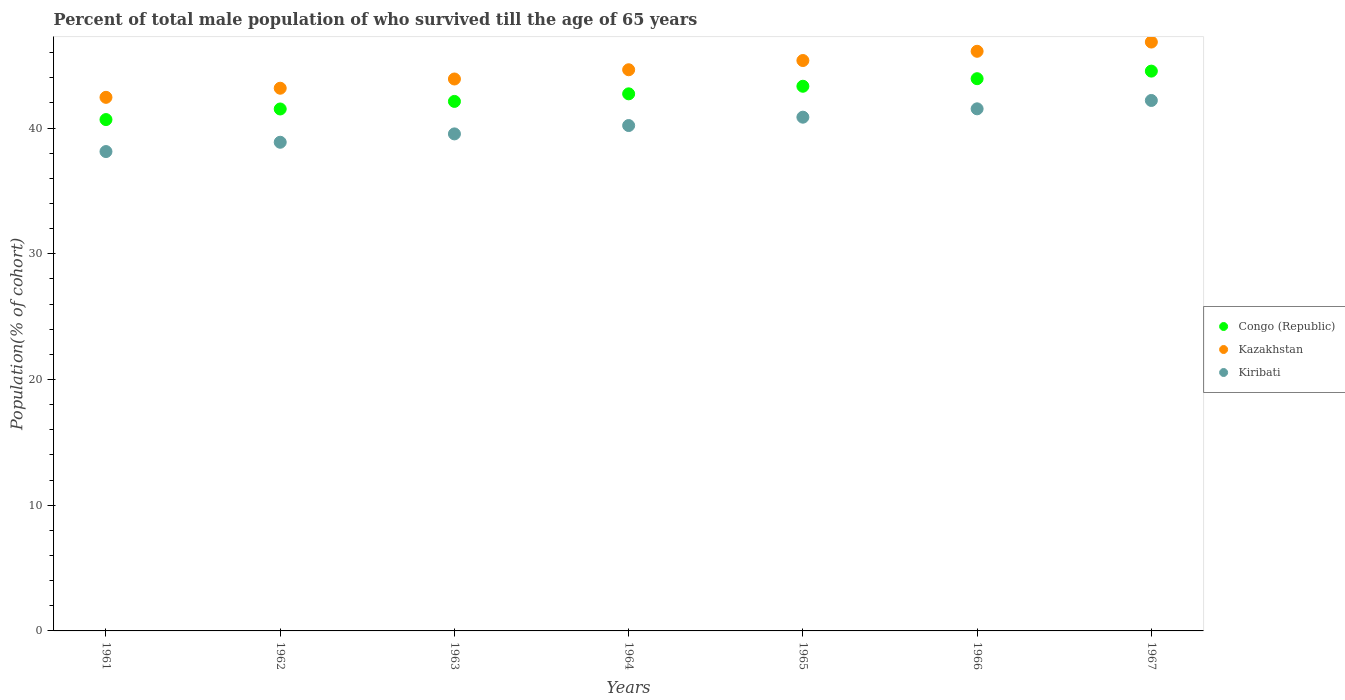How many different coloured dotlines are there?
Offer a very short reply. 3. Is the number of dotlines equal to the number of legend labels?
Your answer should be very brief. Yes. What is the percentage of total male population who survived till the age of 65 years in Congo (Republic) in 1961?
Your answer should be very brief. 40.68. Across all years, what is the maximum percentage of total male population who survived till the age of 65 years in Congo (Republic)?
Your answer should be compact. 44.53. Across all years, what is the minimum percentage of total male population who survived till the age of 65 years in Kiribati?
Offer a very short reply. 38.13. In which year was the percentage of total male population who survived till the age of 65 years in Kazakhstan maximum?
Provide a succinct answer. 1967. In which year was the percentage of total male population who survived till the age of 65 years in Kazakhstan minimum?
Your answer should be compact. 1961. What is the total percentage of total male population who survived till the age of 65 years in Kazakhstan in the graph?
Make the answer very short. 312.5. What is the difference between the percentage of total male population who survived till the age of 65 years in Congo (Republic) in 1965 and that in 1966?
Your answer should be very brief. -0.6. What is the difference between the percentage of total male population who survived till the age of 65 years in Kazakhstan in 1967 and the percentage of total male population who survived till the age of 65 years in Congo (Republic) in 1964?
Your answer should be very brief. 4.12. What is the average percentage of total male population who survived till the age of 65 years in Congo (Republic) per year?
Ensure brevity in your answer.  42.69. In the year 1965, what is the difference between the percentage of total male population who survived till the age of 65 years in Congo (Republic) and percentage of total male population who survived till the age of 65 years in Kiribati?
Make the answer very short. 2.46. What is the ratio of the percentage of total male population who survived till the age of 65 years in Congo (Republic) in 1963 to that in 1967?
Your response must be concise. 0.95. Is the percentage of total male population who survived till the age of 65 years in Kiribati in 1961 less than that in 1964?
Provide a succinct answer. Yes. Is the difference between the percentage of total male population who survived till the age of 65 years in Congo (Republic) in 1961 and 1962 greater than the difference between the percentage of total male population who survived till the age of 65 years in Kiribati in 1961 and 1962?
Keep it short and to the point. No. What is the difference between the highest and the second highest percentage of total male population who survived till the age of 65 years in Kazakhstan?
Ensure brevity in your answer.  0.73. What is the difference between the highest and the lowest percentage of total male population who survived till the age of 65 years in Kiribati?
Offer a very short reply. 4.06. Is it the case that in every year, the sum of the percentage of total male population who survived till the age of 65 years in Congo (Republic) and percentage of total male population who survived till the age of 65 years in Kazakhstan  is greater than the percentage of total male population who survived till the age of 65 years in Kiribati?
Your answer should be compact. Yes. Is the percentage of total male population who survived till the age of 65 years in Kiribati strictly greater than the percentage of total male population who survived till the age of 65 years in Kazakhstan over the years?
Your response must be concise. No. Is the percentage of total male population who survived till the age of 65 years in Congo (Republic) strictly less than the percentage of total male population who survived till the age of 65 years in Kazakhstan over the years?
Your response must be concise. Yes. How many dotlines are there?
Your response must be concise. 3. How many years are there in the graph?
Your answer should be compact. 7. Does the graph contain any zero values?
Keep it short and to the point. No. Where does the legend appear in the graph?
Keep it short and to the point. Center right. How many legend labels are there?
Your answer should be compact. 3. What is the title of the graph?
Give a very brief answer. Percent of total male population of who survived till the age of 65 years. Does "Belgium" appear as one of the legend labels in the graph?
Make the answer very short. No. What is the label or title of the X-axis?
Keep it short and to the point. Years. What is the label or title of the Y-axis?
Give a very brief answer. Population(% of cohort). What is the Population(% of cohort) of Congo (Republic) in 1961?
Your answer should be compact. 40.68. What is the Population(% of cohort) of Kazakhstan in 1961?
Provide a short and direct response. 42.45. What is the Population(% of cohort) in Kiribati in 1961?
Provide a short and direct response. 38.13. What is the Population(% of cohort) of Congo (Republic) in 1962?
Offer a very short reply. 41.52. What is the Population(% of cohort) of Kazakhstan in 1962?
Offer a terse response. 43.17. What is the Population(% of cohort) in Kiribati in 1962?
Ensure brevity in your answer.  38.87. What is the Population(% of cohort) of Congo (Republic) in 1963?
Ensure brevity in your answer.  42.12. What is the Population(% of cohort) in Kazakhstan in 1963?
Give a very brief answer. 43.91. What is the Population(% of cohort) in Kiribati in 1963?
Ensure brevity in your answer.  39.54. What is the Population(% of cohort) of Congo (Republic) in 1964?
Give a very brief answer. 42.73. What is the Population(% of cohort) in Kazakhstan in 1964?
Keep it short and to the point. 44.64. What is the Population(% of cohort) in Kiribati in 1964?
Keep it short and to the point. 40.2. What is the Population(% of cohort) in Congo (Republic) in 1965?
Make the answer very short. 43.33. What is the Population(% of cohort) of Kazakhstan in 1965?
Ensure brevity in your answer.  45.38. What is the Population(% of cohort) in Kiribati in 1965?
Offer a very short reply. 40.87. What is the Population(% of cohort) of Congo (Republic) in 1966?
Offer a terse response. 43.93. What is the Population(% of cohort) of Kazakhstan in 1966?
Your answer should be compact. 46.11. What is the Population(% of cohort) of Kiribati in 1966?
Provide a succinct answer. 41.53. What is the Population(% of cohort) of Congo (Republic) in 1967?
Your response must be concise. 44.53. What is the Population(% of cohort) in Kazakhstan in 1967?
Provide a succinct answer. 46.85. What is the Population(% of cohort) of Kiribati in 1967?
Provide a succinct answer. 42.2. Across all years, what is the maximum Population(% of cohort) of Congo (Republic)?
Offer a very short reply. 44.53. Across all years, what is the maximum Population(% of cohort) in Kazakhstan?
Your answer should be very brief. 46.85. Across all years, what is the maximum Population(% of cohort) in Kiribati?
Offer a very short reply. 42.2. Across all years, what is the minimum Population(% of cohort) of Congo (Republic)?
Your response must be concise. 40.68. Across all years, what is the minimum Population(% of cohort) of Kazakhstan?
Your answer should be compact. 42.45. Across all years, what is the minimum Population(% of cohort) of Kiribati?
Offer a very short reply. 38.13. What is the total Population(% of cohort) of Congo (Republic) in the graph?
Give a very brief answer. 298.84. What is the total Population(% of cohort) of Kazakhstan in the graph?
Offer a very short reply. 312.5. What is the total Population(% of cohort) of Kiribati in the graph?
Keep it short and to the point. 281.35. What is the difference between the Population(% of cohort) in Congo (Republic) in 1961 and that in 1962?
Keep it short and to the point. -0.84. What is the difference between the Population(% of cohort) of Kazakhstan in 1961 and that in 1962?
Ensure brevity in your answer.  -0.73. What is the difference between the Population(% of cohort) of Kiribati in 1961 and that in 1962?
Keep it short and to the point. -0.74. What is the difference between the Population(% of cohort) in Congo (Republic) in 1961 and that in 1963?
Your answer should be compact. -1.45. What is the difference between the Population(% of cohort) of Kazakhstan in 1961 and that in 1963?
Provide a short and direct response. -1.46. What is the difference between the Population(% of cohort) of Kiribati in 1961 and that in 1963?
Make the answer very short. -1.41. What is the difference between the Population(% of cohort) in Congo (Republic) in 1961 and that in 1964?
Give a very brief answer. -2.05. What is the difference between the Population(% of cohort) of Kazakhstan in 1961 and that in 1964?
Ensure brevity in your answer.  -2.19. What is the difference between the Population(% of cohort) of Kiribati in 1961 and that in 1964?
Your answer should be very brief. -2.07. What is the difference between the Population(% of cohort) in Congo (Republic) in 1961 and that in 1965?
Your answer should be compact. -2.65. What is the difference between the Population(% of cohort) in Kazakhstan in 1961 and that in 1965?
Keep it short and to the point. -2.93. What is the difference between the Population(% of cohort) in Kiribati in 1961 and that in 1965?
Ensure brevity in your answer.  -2.73. What is the difference between the Population(% of cohort) in Congo (Republic) in 1961 and that in 1966?
Keep it short and to the point. -3.25. What is the difference between the Population(% of cohort) in Kazakhstan in 1961 and that in 1966?
Your answer should be compact. -3.66. What is the difference between the Population(% of cohort) in Kiribati in 1961 and that in 1966?
Provide a succinct answer. -3.4. What is the difference between the Population(% of cohort) of Congo (Republic) in 1961 and that in 1967?
Give a very brief answer. -3.85. What is the difference between the Population(% of cohort) in Kazakhstan in 1961 and that in 1967?
Your response must be concise. -4.4. What is the difference between the Population(% of cohort) in Kiribati in 1961 and that in 1967?
Offer a very short reply. -4.06. What is the difference between the Population(% of cohort) in Congo (Republic) in 1962 and that in 1963?
Keep it short and to the point. -0.6. What is the difference between the Population(% of cohort) in Kazakhstan in 1962 and that in 1963?
Your response must be concise. -0.73. What is the difference between the Population(% of cohort) of Kiribati in 1962 and that in 1963?
Offer a terse response. -0.66. What is the difference between the Population(% of cohort) in Congo (Republic) in 1962 and that in 1964?
Give a very brief answer. -1.2. What is the difference between the Population(% of cohort) of Kazakhstan in 1962 and that in 1964?
Your answer should be compact. -1.47. What is the difference between the Population(% of cohort) in Kiribati in 1962 and that in 1964?
Ensure brevity in your answer.  -1.33. What is the difference between the Population(% of cohort) of Congo (Republic) in 1962 and that in 1965?
Provide a succinct answer. -1.81. What is the difference between the Population(% of cohort) in Kazakhstan in 1962 and that in 1965?
Your answer should be compact. -2.2. What is the difference between the Population(% of cohort) of Kiribati in 1962 and that in 1965?
Your answer should be compact. -1.99. What is the difference between the Population(% of cohort) in Congo (Republic) in 1962 and that in 1966?
Give a very brief answer. -2.41. What is the difference between the Population(% of cohort) of Kazakhstan in 1962 and that in 1966?
Make the answer very short. -2.94. What is the difference between the Population(% of cohort) in Kiribati in 1962 and that in 1966?
Ensure brevity in your answer.  -2.66. What is the difference between the Population(% of cohort) of Congo (Republic) in 1962 and that in 1967?
Offer a very short reply. -3.01. What is the difference between the Population(% of cohort) of Kazakhstan in 1962 and that in 1967?
Make the answer very short. -3.67. What is the difference between the Population(% of cohort) in Kiribati in 1962 and that in 1967?
Give a very brief answer. -3.32. What is the difference between the Population(% of cohort) of Congo (Republic) in 1963 and that in 1964?
Ensure brevity in your answer.  -0.6. What is the difference between the Population(% of cohort) of Kazakhstan in 1963 and that in 1964?
Your answer should be compact. -0.73. What is the difference between the Population(% of cohort) in Kiribati in 1963 and that in 1964?
Provide a short and direct response. -0.66. What is the difference between the Population(% of cohort) of Congo (Republic) in 1963 and that in 1965?
Provide a succinct answer. -1.2. What is the difference between the Population(% of cohort) in Kazakhstan in 1963 and that in 1965?
Keep it short and to the point. -1.47. What is the difference between the Population(% of cohort) of Kiribati in 1963 and that in 1965?
Offer a very short reply. -1.33. What is the difference between the Population(% of cohort) of Congo (Republic) in 1963 and that in 1966?
Ensure brevity in your answer.  -1.81. What is the difference between the Population(% of cohort) in Kazakhstan in 1963 and that in 1966?
Your answer should be compact. -2.2. What is the difference between the Population(% of cohort) of Kiribati in 1963 and that in 1966?
Your answer should be compact. -1.99. What is the difference between the Population(% of cohort) of Congo (Republic) in 1963 and that in 1967?
Offer a terse response. -2.41. What is the difference between the Population(% of cohort) in Kazakhstan in 1963 and that in 1967?
Your response must be concise. -2.94. What is the difference between the Population(% of cohort) of Kiribati in 1963 and that in 1967?
Your answer should be very brief. -2.66. What is the difference between the Population(% of cohort) in Congo (Republic) in 1964 and that in 1965?
Make the answer very short. -0.6. What is the difference between the Population(% of cohort) of Kazakhstan in 1964 and that in 1965?
Your answer should be compact. -0.73. What is the difference between the Population(% of cohort) of Kiribati in 1964 and that in 1965?
Your answer should be compact. -0.66. What is the difference between the Population(% of cohort) of Congo (Republic) in 1964 and that in 1966?
Offer a terse response. -1.2. What is the difference between the Population(% of cohort) in Kazakhstan in 1964 and that in 1966?
Provide a succinct answer. -1.47. What is the difference between the Population(% of cohort) in Kiribati in 1964 and that in 1966?
Your answer should be compact. -1.33. What is the difference between the Population(% of cohort) of Congo (Republic) in 1964 and that in 1967?
Your response must be concise. -1.81. What is the difference between the Population(% of cohort) of Kazakhstan in 1964 and that in 1967?
Offer a terse response. -2.2. What is the difference between the Population(% of cohort) in Kiribati in 1964 and that in 1967?
Provide a succinct answer. -1.99. What is the difference between the Population(% of cohort) of Congo (Republic) in 1965 and that in 1966?
Your answer should be compact. -0.6. What is the difference between the Population(% of cohort) in Kazakhstan in 1965 and that in 1966?
Offer a very short reply. -0.73. What is the difference between the Population(% of cohort) of Kiribati in 1965 and that in 1966?
Keep it short and to the point. -0.66. What is the difference between the Population(% of cohort) in Congo (Republic) in 1965 and that in 1967?
Your answer should be compact. -1.2. What is the difference between the Population(% of cohort) in Kazakhstan in 1965 and that in 1967?
Keep it short and to the point. -1.47. What is the difference between the Population(% of cohort) of Kiribati in 1965 and that in 1967?
Your response must be concise. -1.33. What is the difference between the Population(% of cohort) in Congo (Republic) in 1966 and that in 1967?
Make the answer very short. -0.6. What is the difference between the Population(% of cohort) of Kazakhstan in 1966 and that in 1967?
Make the answer very short. -0.73. What is the difference between the Population(% of cohort) of Kiribati in 1966 and that in 1967?
Provide a short and direct response. -0.66. What is the difference between the Population(% of cohort) of Congo (Republic) in 1961 and the Population(% of cohort) of Kazakhstan in 1962?
Offer a very short reply. -2.49. What is the difference between the Population(% of cohort) of Congo (Republic) in 1961 and the Population(% of cohort) of Kiribati in 1962?
Ensure brevity in your answer.  1.8. What is the difference between the Population(% of cohort) in Kazakhstan in 1961 and the Population(% of cohort) in Kiribati in 1962?
Ensure brevity in your answer.  3.57. What is the difference between the Population(% of cohort) of Congo (Republic) in 1961 and the Population(% of cohort) of Kazakhstan in 1963?
Keep it short and to the point. -3.23. What is the difference between the Population(% of cohort) of Congo (Republic) in 1961 and the Population(% of cohort) of Kiribati in 1963?
Keep it short and to the point. 1.14. What is the difference between the Population(% of cohort) in Kazakhstan in 1961 and the Population(% of cohort) in Kiribati in 1963?
Offer a terse response. 2.91. What is the difference between the Population(% of cohort) of Congo (Republic) in 1961 and the Population(% of cohort) of Kazakhstan in 1964?
Provide a short and direct response. -3.96. What is the difference between the Population(% of cohort) of Congo (Republic) in 1961 and the Population(% of cohort) of Kiribati in 1964?
Your answer should be very brief. 0.47. What is the difference between the Population(% of cohort) in Kazakhstan in 1961 and the Population(% of cohort) in Kiribati in 1964?
Your answer should be compact. 2.24. What is the difference between the Population(% of cohort) in Congo (Republic) in 1961 and the Population(% of cohort) in Kazakhstan in 1965?
Your answer should be compact. -4.7. What is the difference between the Population(% of cohort) of Congo (Republic) in 1961 and the Population(% of cohort) of Kiribati in 1965?
Give a very brief answer. -0.19. What is the difference between the Population(% of cohort) in Kazakhstan in 1961 and the Population(% of cohort) in Kiribati in 1965?
Give a very brief answer. 1.58. What is the difference between the Population(% of cohort) in Congo (Republic) in 1961 and the Population(% of cohort) in Kazakhstan in 1966?
Make the answer very short. -5.43. What is the difference between the Population(% of cohort) in Congo (Republic) in 1961 and the Population(% of cohort) in Kiribati in 1966?
Keep it short and to the point. -0.85. What is the difference between the Population(% of cohort) in Kazakhstan in 1961 and the Population(% of cohort) in Kiribati in 1966?
Make the answer very short. 0.91. What is the difference between the Population(% of cohort) of Congo (Republic) in 1961 and the Population(% of cohort) of Kazakhstan in 1967?
Make the answer very short. -6.17. What is the difference between the Population(% of cohort) of Congo (Republic) in 1961 and the Population(% of cohort) of Kiribati in 1967?
Offer a very short reply. -1.52. What is the difference between the Population(% of cohort) of Kazakhstan in 1961 and the Population(% of cohort) of Kiribati in 1967?
Ensure brevity in your answer.  0.25. What is the difference between the Population(% of cohort) in Congo (Republic) in 1962 and the Population(% of cohort) in Kazakhstan in 1963?
Provide a short and direct response. -2.39. What is the difference between the Population(% of cohort) in Congo (Republic) in 1962 and the Population(% of cohort) in Kiribati in 1963?
Offer a very short reply. 1.98. What is the difference between the Population(% of cohort) in Kazakhstan in 1962 and the Population(% of cohort) in Kiribati in 1963?
Provide a succinct answer. 3.63. What is the difference between the Population(% of cohort) of Congo (Republic) in 1962 and the Population(% of cohort) of Kazakhstan in 1964?
Offer a very short reply. -3.12. What is the difference between the Population(% of cohort) in Congo (Republic) in 1962 and the Population(% of cohort) in Kiribati in 1964?
Keep it short and to the point. 1.32. What is the difference between the Population(% of cohort) of Kazakhstan in 1962 and the Population(% of cohort) of Kiribati in 1964?
Provide a succinct answer. 2.97. What is the difference between the Population(% of cohort) in Congo (Republic) in 1962 and the Population(% of cohort) in Kazakhstan in 1965?
Your response must be concise. -3.86. What is the difference between the Population(% of cohort) of Congo (Republic) in 1962 and the Population(% of cohort) of Kiribati in 1965?
Provide a short and direct response. 0.65. What is the difference between the Population(% of cohort) of Kazakhstan in 1962 and the Population(% of cohort) of Kiribati in 1965?
Your response must be concise. 2.3. What is the difference between the Population(% of cohort) in Congo (Republic) in 1962 and the Population(% of cohort) in Kazakhstan in 1966?
Provide a short and direct response. -4.59. What is the difference between the Population(% of cohort) of Congo (Republic) in 1962 and the Population(% of cohort) of Kiribati in 1966?
Ensure brevity in your answer.  -0.01. What is the difference between the Population(% of cohort) of Kazakhstan in 1962 and the Population(% of cohort) of Kiribati in 1966?
Provide a short and direct response. 1.64. What is the difference between the Population(% of cohort) of Congo (Republic) in 1962 and the Population(% of cohort) of Kazakhstan in 1967?
Offer a very short reply. -5.32. What is the difference between the Population(% of cohort) of Congo (Republic) in 1962 and the Population(% of cohort) of Kiribati in 1967?
Offer a very short reply. -0.68. What is the difference between the Population(% of cohort) of Kazakhstan in 1962 and the Population(% of cohort) of Kiribati in 1967?
Your answer should be compact. 0.97. What is the difference between the Population(% of cohort) of Congo (Republic) in 1963 and the Population(% of cohort) of Kazakhstan in 1964?
Your answer should be compact. -2.52. What is the difference between the Population(% of cohort) in Congo (Republic) in 1963 and the Population(% of cohort) in Kiribati in 1964?
Make the answer very short. 1.92. What is the difference between the Population(% of cohort) in Kazakhstan in 1963 and the Population(% of cohort) in Kiribati in 1964?
Provide a short and direct response. 3.7. What is the difference between the Population(% of cohort) in Congo (Republic) in 1963 and the Population(% of cohort) in Kazakhstan in 1965?
Offer a terse response. -3.25. What is the difference between the Population(% of cohort) in Congo (Republic) in 1963 and the Population(% of cohort) in Kiribati in 1965?
Your answer should be compact. 1.25. What is the difference between the Population(% of cohort) in Kazakhstan in 1963 and the Population(% of cohort) in Kiribati in 1965?
Keep it short and to the point. 3.04. What is the difference between the Population(% of cohort) in Congo (Republic) in 1963 and the Population(% of cohort) in Kazakhstan in 1966?
Offer a very short reply. -3.99. What is the difference between the Population(% of cohort) of Congo (Republic) in 1963 and the Population(% of cohort) of Kiribati in 1966?
Give a very brief answer. 0.59. What is the difference between the Population(% of cohort) in Kazakhstan in 1963 and the Population(% of cohort) in Kiribati in 1966?
Give a very brief answer. 2.37. What is the difference between the Population(% of cohort) in Congo (Republic) in 1963 and the Population(% of cohort) in Kazakhstan in 1967?
Offer a very short reply. -4.72. What is the difference between the Population(% of cohort) in Congo (Republic) in 1963 and the Population(% of cohort) in Kiribati in 1967?
Keep it short and to the point. -0.07. What is the difference between the Population(% of cohort) in Kazakhstan in 1963 and the Population(% of cohort) in Kiribati in 1967?
Ensure brevity in your answer.  1.71. What is the difference between the Population(% of cohort) of Congo (Republic) in 1964 and the Population(% of cohort) of Kazakhstan in 1965?
Give a very brief answer. -2.65. What is the difference between the Population(% of cohort) of Congo (Republic) in 1964 and the Population(% of cohort) of Kiribati in 1965?
Give a very brief answer. 1.86. What is the difference between the Population(% of cohort) of Kazakhstan in 1964 and the Population(% of cohort) of Kiribati in 1965?
Give a very brief answer. 3.77. What is the difference between the Population(% of cohort) of Congo (Republic) in 1964 and the Population(% of cohort) of Kazakhstan in 1966?
Keep it short and to the point. -3.38. What is the difference between the Population(% of cohort) in Congo (Republic) in 1964 and the Population(% of cohort) in Kiribati in 1966?
Ensure brevity in your answer.  1.19. What is the difference between the Population(% of cohort) in Kazakhstan in 1964 and the Population(% of cohort) in Kiribati in 1966?
Provide a succinct answer. 3.11. What is the difference between the Population(% of cohort) of Congo (Republic) in 1964 and the Population(% of cohort) of Kazakhstan in 1967?
Give a very brief answer. -4.12. What is the difference between the Population(% of cohort) in Congo (Republic) in 1964 and the Population(% of cohort) in Kiribati in 1967?
Offer a very short reply. 0.53. What is the difference between the Population(% of cohort) in Kazakhstan in 1964 and the Population(% of cohort) in Kiribati in 1967?
Offer a very short reply. 2.44. What is the difference between the Population(% of cohort) in Congo (Republic) in 1965 and the Population(% of cohort) in Kazakhstan in 1966?
Provide a short and direct response. -2.78. What is the difference between the Population(% of cohort) of Congo (Republic) in 1965 and the Population(% of cohort) of Kiribati in 1966?
Keep it short and to the point. 1.8. What is the difference between the Population(% of cohort) in Kazakhstan in 1965 and the Population(% of cohort) in Kiribati in 1966?
Keep it short and to the point. 3.84. What is the difference between the Population(% of cohort) of Congo (Republic) in 1965 and the Population(% of cohort) of Kazakhstan in 1967?
Provide a short and direct response. -3.52. What is the difference between the Population(% of cohort) of Congo (Republic) in 1965 and the Population(% of cohort) of Kiribati in 1967?
Provide a short and direct response. 1.13. What is the difference between the Population(% of cohort) in Kazakhstan in 1965 and the Population(% of cohort) in Kiribati in 1967?
Keep it short and to the point. 3.18. What is the difference between the Population(% of cohort) of Congo (Republic) in 1966 and the Population(% of cohort) of Kazakhstan in 1967?
Offer a very short reply. -2.91. What is the difference between the Population(% of cohort) of Congo (Republic) in 1966 and the Population(% of cohort) of Kiribati in 1967?
Provide a succinct answer. 1.73. What is the difference between the Population(% of cohort) in Kazakhstan in 1966 and the Population(% of cohort) in Kiribati in 1967?
Offer a very short reply. 3.91. What is the average Population(% of cohort) in Congo (Republic) per year?
Your answer should be compact. 42.69. What is the average Population(% of cohort) in Kazakhstan per year?
Offer a very short reply. 44.64. What is the average Population(% of cohort) of Kiribati per year?
Your response must be concise. 40.19. In the year 1961, what is the difference between the Population(% of cohort) in Congo (Republic) and Population(% of cohort) in Kazakhstan?
Offer a very short reply. -1.77. In the year 1961, what is the difference between the Population(% of cohort) in Congo (Republic) and Population(% of cohort) in Kiribati?
Offer a terse response. 2.54. In the year 1961, what is the difference between the Population(% of cohort) in Kazakhstan and Population(% of cohort) in Kiribati?
Ensure brevity in your answer.  4.31. In the year 1962, what is the difference between the Population(% of cohort) of Congo (Republic) and Population(% of cohort) of Kazakhstan?
Your response must be concise. -1.65. In the year 1962, what is the difference between the Population(% of cohort) of Congo (Republic) and Population(% of cohort) of Kiribati?
Your answer should be compact. 2.65. In the year 1962, what is the difference between the Population(% of cohort) of Kazakhstan and Population(% of cohort) of Kiribati?
Give a very brief answer. 4.3. In the year 1963, what is the difference between the Population(% of cohort) in Congo (Republic) and Population(% of cohort) in Kazakhstan?
Provide a succinct answer. -1.78. In the year 1963, what is the difference between the Population(% of cohort) of Congo (Republic) and Population(% of cohort) of Kiribati?
Keep it short and to the point. 2.58. In the year 1963, what is the difference between the Population(% of cohort) in Kazakhstan and Population(% of cohort) in Kiribati?
Provide a short and direct response. 4.37. In the year 1964, what is the difference between the Population(% of cohort) of Congo (Republic) and Population(% of cohort) of Kazakhstan?
Keep it short and to the point. -1.92. In the year 1964, what is the difference between the Population(% of cohort) of Congo (Republic) and Population(% of cohort) of Kiribati?
Your answer should be compact. 2.52. In the year 1964, what is the difference between the Population(% of cohort) of Kazakhstan and Population(% of cohort) of Kiribati?
Your answer should be very brief. 4.44. In the year 1965, what is the difference between the Population(% of cohort) in Congo (Republic) and Population(% of cohort) in Kazakhstan?
Offer a terse response. -2.05. In the year 1965, what is the difference between the Population(% of cohort) in Congo (Republic) and Population(% of cohort) in Kiribati?
Ensure brevity in your answer.  2.46. In the year 1965, what is the difference between the Population(% of cohort) of Kazakhstan and Population(% of cohort) of Kiribati?
Your response must be concise. 4.51. In the year 1966, what is the difference between the Population(% of cohort) of Congo (Republic) and Population(% of cohort) of Kazakhstan?
Provide a succinct answer. -2.18. In the year 1966, what is the difference between the Population(% of cohort) in Congo (Republic) and Population(% of cohort) in Kiribati?
Keep it short and to the point. 2.4. In the year 1966, what is the difference between the Population(% of cohort) of Kazakhstan and Population(% of cohort) of Kiribati?
Give a very brief answer. 4.58. In the year 1967, what is the difference between the Population(% of cohort) of Congo (Republic) and Population(% of cohort) of Kazakhstan?
Keep it short and to the point. -2.31. In the year 1967, what is the difference between the Population(% of cohort) in Congo (Republic) and Population(% of cohort) in Kiribati?
Your answer should be compact. 2.34. In the year 1967, what is the difference between the Population(% of cohort) in Kazakhstan and Population(% of cohort) in Kiribati?
Keep it short and to the point. 4.65. What is the ratio of the Population(% of cohort) of Congo (Republic) in 1961 to that in 1962?
Keep it short and to the point. 0.98. What is the ratio of the Population(% of cohort) of Kazakhstan in 1961 to that in 1962?
Give a very brief answer. 0.98. What is the ratio of the Population(% of cohort) in Congo (Republic) in 1961 to that in 1963?
Provide a succinct answer. 0.97. What is the ratio of the Population(% of cohort) in Kazakhstan in 1961 to that in 1963?
Give a very brief answer. 0.97. What is the ratio of the Population(% of cohort) in Kiribati in 1961 to that in 1963?
Ensure brevity in your answer.  0.96. What is the ratio of the Population(% of cohort) of Congo (Republic) in 1961 to that in 1964?
Provide a short and direct response. 0.95. What is the ratio of the Population(% of cohort) in Kazakhstan in 1961 to that in 1964?
Your answer should be very brief. 0.95. What is the ratio of the Population(% of cohort) of Kiribati in 1961 to that in 1964?
Provide a succinct answer. 0.95. What is the ratio of the Population(% of cohort) in Congo (Republic) in 1961 to that in 1965?
Your response must be concise. 0.94. What is the ratio of the Population(% of cohort) in Kazakhstan in 1961 to that in 1965?
Provide a succinct answer. 0.94. What is the ratio of the Population(% of cohort) in Kiribati in 1961 to that in 1965?
Your response must be concise. 0.93. What is the ratio of the Population(% of cohort) of Congo (Republic) in 1961 to that in 1966?
Your answer should be very brief. 0.93. What is the ratio of the Population(% of cohort) of Kazakhstan in 1961 to that in 1966?
Give a very brief answer. 0.92. What is the ratio of the Population(% of cohort) of Kiribati in 1961 to that in 1966?
Provide a short and direct response. 0.92. What is the ratio of the Population(% of cohort) of Congo (Republic) in 1961 to that in 1967?
Offer a very short reply. 0.91. What is the ratio of the Population(% of cohort) in Kazakhstan in 1961 to that in 1967?
Your answer should be very brief. 0.91. What is the ratio of the Population(% of cohort) of Kiribati in 1961 to that in 1967?
Offer a terse response. 0.9. What is the ratio of the Population(% of cohort) of Congo (Republic) in 1962 to that in 1963?
Offer a terse response. 0.99. What is the ratio of the Population(% of cohort) of Kazakhstan in 1962 to that in 1963?
Provide a short and direct response. 0.98. What is the ratio of the Population(% of cohort) in Kiribati in 1962 to that in 1963?
Provide a succinct answer. 0.98. What is the ratio of the Population(% of cohort) in Congo (Republic) in 1962 to that in 1964?
Provide a succinct answer. 0.97. What is the ratio of the Population(% of cohort) of Kazakhstan in 1962 to that in 1964?
Your response must be concise. 0.97. What is the ratio of the Population(% of cohort) in Kiribati in 1962 to that in 1964?
Your answer should be compact. 0.97. What is the ratio of the Population(% of cohort) of Kazakhstan in 1962 to that in 1965?
Make the answer very short. 0.95. What is the ratio of the Population(% of cohort) in Kiribati in 1962 to that in 1965?
Your response must be concise. 0.95. What is the ratio of the Population(% of cohort) of Congo (Republic) in 1962 to that in 1966?
Offer a very short reply. 0.95. What is the ratio of the Population(% of cohort) of Kazakhstan in 1962 to that in 1966?
Provide a short and direct response. 0.94. What is the ratio of the Population(% of cohort) in Kiribati in 1962 to that in 1966?
Provide a succinct answer. 0.94. What is the ratio of the Population(% of cohort) in Congo (Republic) in 1962 to that in 1967?
Your answer should be very brief. 0.93. What is the ratio of the Population(% of cohort) of Kazakhstan in 1962 to that in 1967?
Give a very brief answer. 0.92. What is the ratio of the Population(% of cohort) of Kiribati in 1962 to that in 1967?
Your response must be concise. 0.92. What is the ratio of the Population(% of cohort) of Congo (Republic) in 1963 to that in 1964?
Provide a short and direct response. 0.99. What is the ratio of the Population(% of cohort) of Kazakhstan in 1963 to that in 1964?
Offer a terse response. 0.98. What is the ratio of the Population(% of cohort) of Kiribati in 1963 to that in 1964?
Your answer should be very brief. 0.98. What is the ratio of the Population(% of cohort) in Congo (Republic) in 1963 to that in 1965?
Keep it short and to the point. 0.97. What is the ratio of the Population(% of cohort) of Kazakhstan in 1963 to that in 1965?
Offer a terse response. 0.97. What is the ratio of the Population(% of cohort) of Kiribati in 1963 to that in 1965?
Give a very brief answer. 0.97. What is the ratio of the Population(% of cohort) in Congo (Republic) in 1963 to that in 1966?
Your answer should be compact. 0.96. What is the ratio of the Population(% of cohort) in Kazakhstan in 1963 to that in 1966?
Your response must be concise. 0.95. What is the ratio of the Population(% of cohort) of Congo (Republic) in 1963 to that in 1967?
Your answer should be very brief. 0.95. What is the ratio of the Population(% of cohort) in Kazakhstan in 1963 to that in 1967?
Make the answer very short. 0.94. What is the ratio of the Population(% of cohort) in Kiribati in 1963 to that in 1967?
Keep it short and to the point. 0.94. What is the ratio of the Population(% of cohort) in Congo (Republic) in 1964 to that in 1965?
Give a very brief answer. 0.99. What is the ratio of the Population(% of cohort) in Kazakhstan in 1964 to that in 1965?
Your answer should be very brief. 0.98. What is the ratio of the Population(% of cohort) of Kiribati in 1964 to that in 1965?
Ensure brevity in your answer.  0.98. What is the ratio of the Population(% of cohort) in Congo (Republic) in 1964 to that in 1966?
Ensure brevity in your answer.  0.97. What is the ratio of the Population(% of cohort) of Kazakhstan in 1964 to that in 1966?
Your answer should be very brief. 0.97. What is the ratio of the Population(% of cohort) in Congo (Republic) in 1964 to that in 1967?
Ensure brevity in your answer.  0.96. What is the ratio of the Population(% of cohort) in Kazakhstan in 1964 to that in 1967?
Your answer should be compact. 0.95. What is the ratio of the Population(% of cohort) in Kiribati in 1964 to that in 1967?
Your response must be concise. 0.95. What is the ratio of the Population(% of cohort) in Congo (Republic) in 1965 to that in 1966?
Keep it short and to the point. 0.99. What is the ratio of the Population(% of cohort) of Kazakhstan in 1965 to that in 1966?
Offer a very short reply. 0.98. What is the ratio of the Population(% of cohort) of Congo (Republic) in 1965 to that in 1967?
Keep it short and to the point. 0.97. What is the ratio of the Population(% of cohort) of Kazakhstan in 1965 to that in 1967?
Offer a very short reply. 0.97. What is the ratio of the Population(% of cohort) in Kiribati in 1965 to that in 1967?
Give a very brief answer. 0.97. What is the ratio of the Population(% of cohort) in Congo (Republic) in 1966 to that in 1967?
Your answer should be very brief. 0.99. What is the ratio of the Population(% of cohort) of Kazakhstan in 1966 to that in 1967?
Offer a terse response. 0.98. What is the ratio of the Population(% of cohort) in Kiribati in 1966 to that in 1967?
Keep it short and to the point. 0.98. What is the difference between the highest and the second highest Population(% of cohort) in Congo (Republic)?
Your answer should be very brief. 0.6. What is the difference between the highest and the second highest Population(% of cohort) of Kazakhstan?
Give a very brief answer. 0.73. What is the difference between the highest and the second highest Population(% of cohort) of Kiribati?
Offer a very short reply. 0.66. What is the difference between the highest and the lowest Population(% of cohort) of Congo (Republic)?
Provide a short and direct response. 3.85. What is the difference between the highest and the lowest Population(% of cohort) of Kazakhstan?
Your response must be concise. 4.4. What is the difference between the highest and the lowest Population(% of cohort) in Kiribati?
Your answer should be very brief. 4.06. 